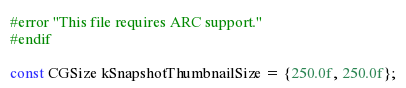<code> <loc_0><loc_0><loc_500><loc_500><_ObjectiveC_>#error "This file requires ARC support."
#endif

const CGSize kSnapshotThumbnailSize = {250.0f, 250.0f};
</code> 